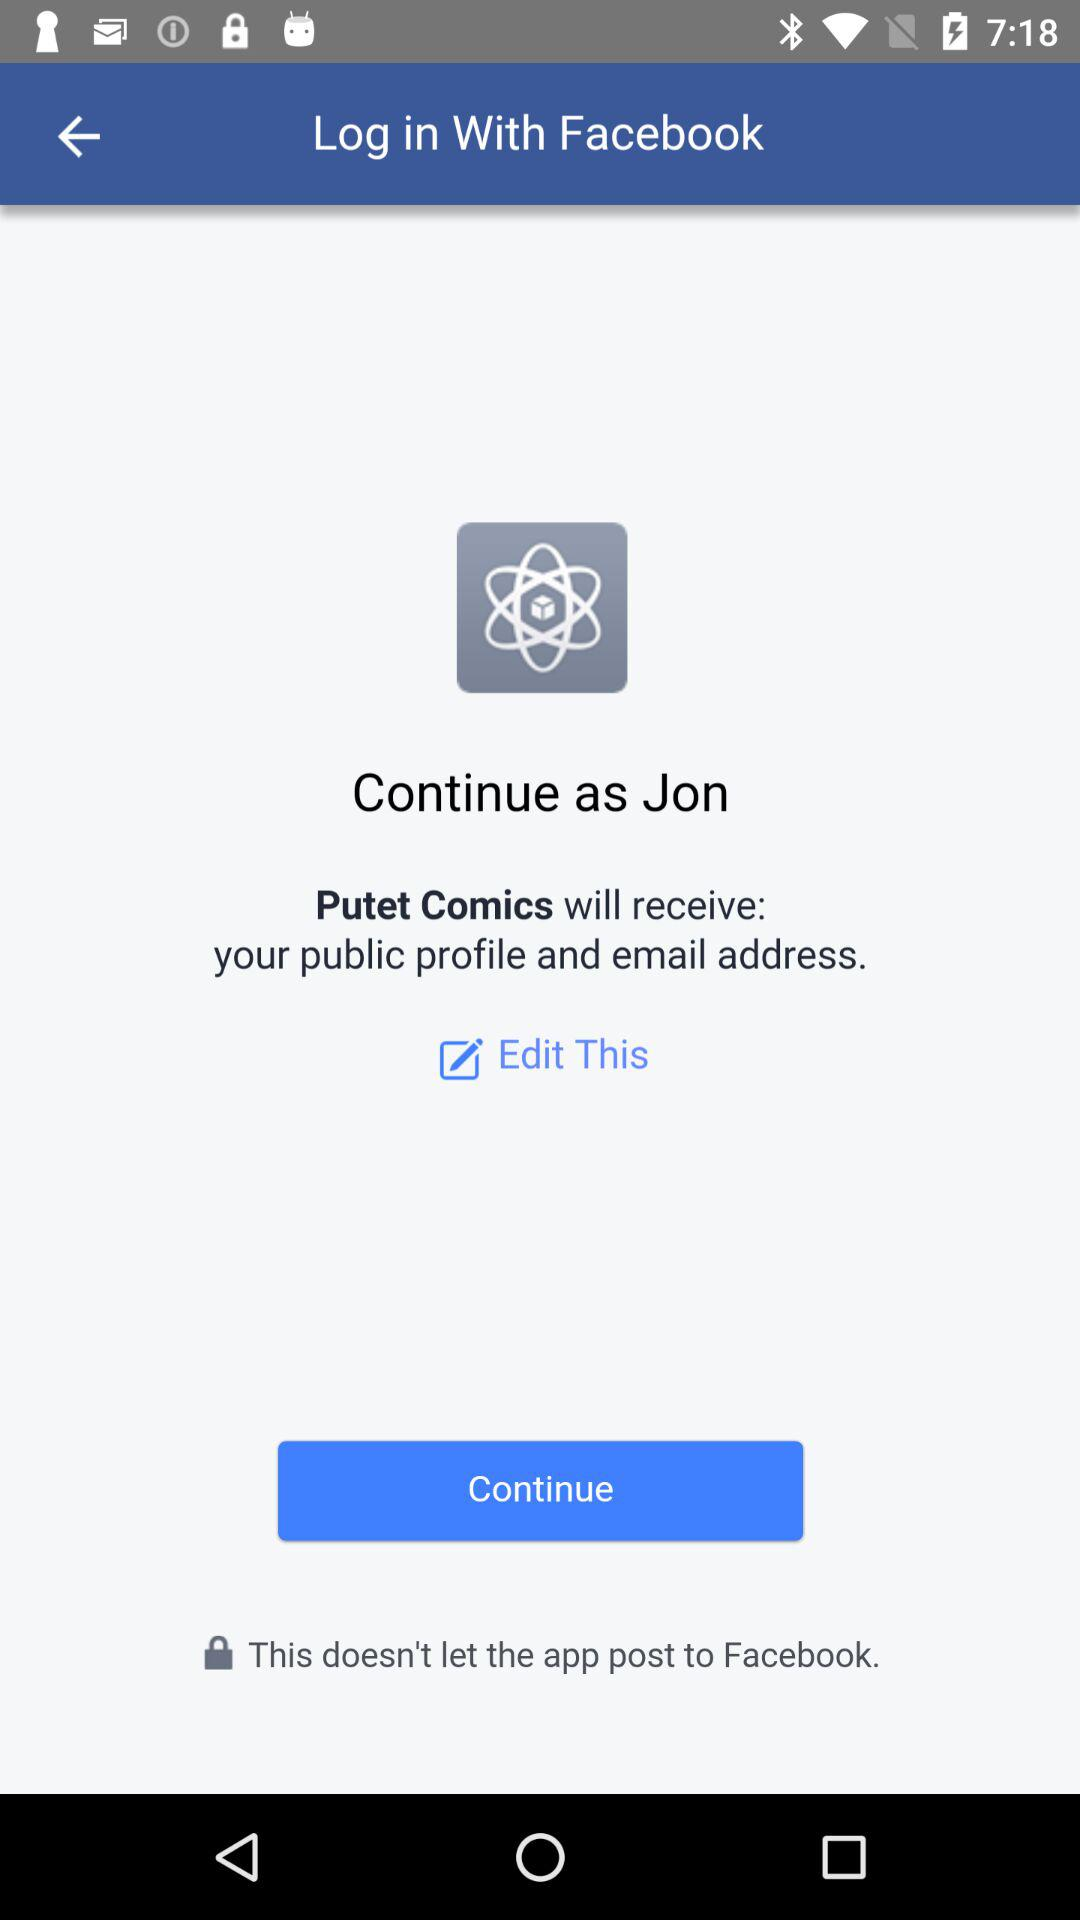What is the user name? The user name is Jon. 